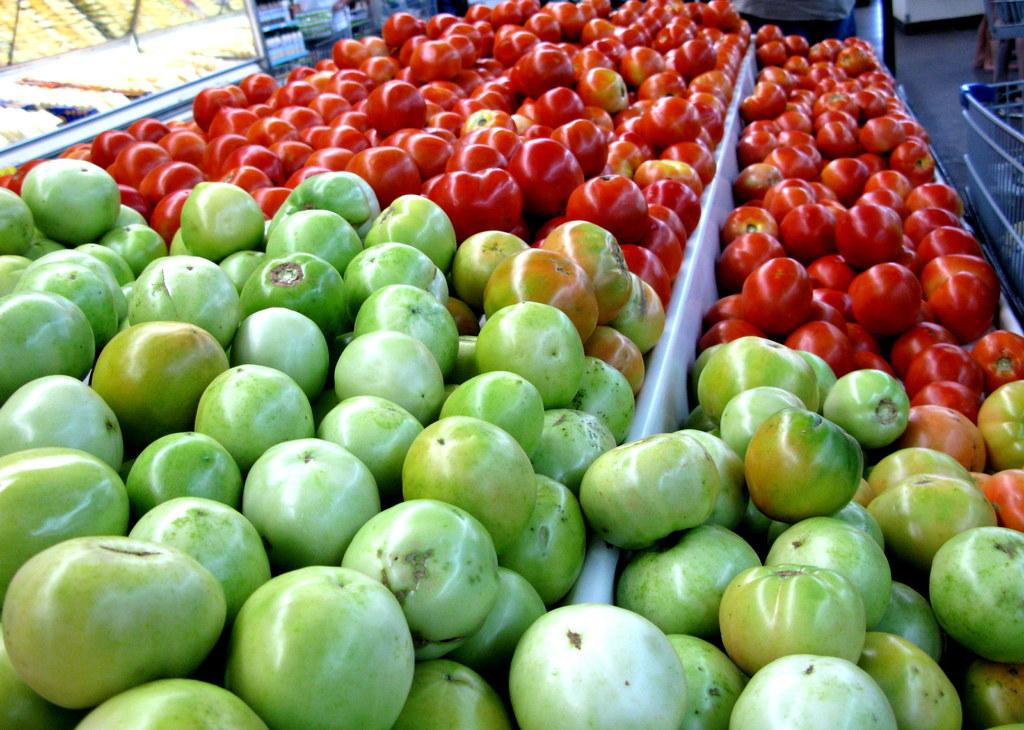What type of food can be seen in the image? There are tomatoes in the image. What time is displayed on the clock in the image? There is no clock present in the image; it only features tomatoes. What is the weight of the tomatoes in the image? The weight of the tomatoes cannot be determined from the image alone, as it does not provide any information about their size or quantity. 